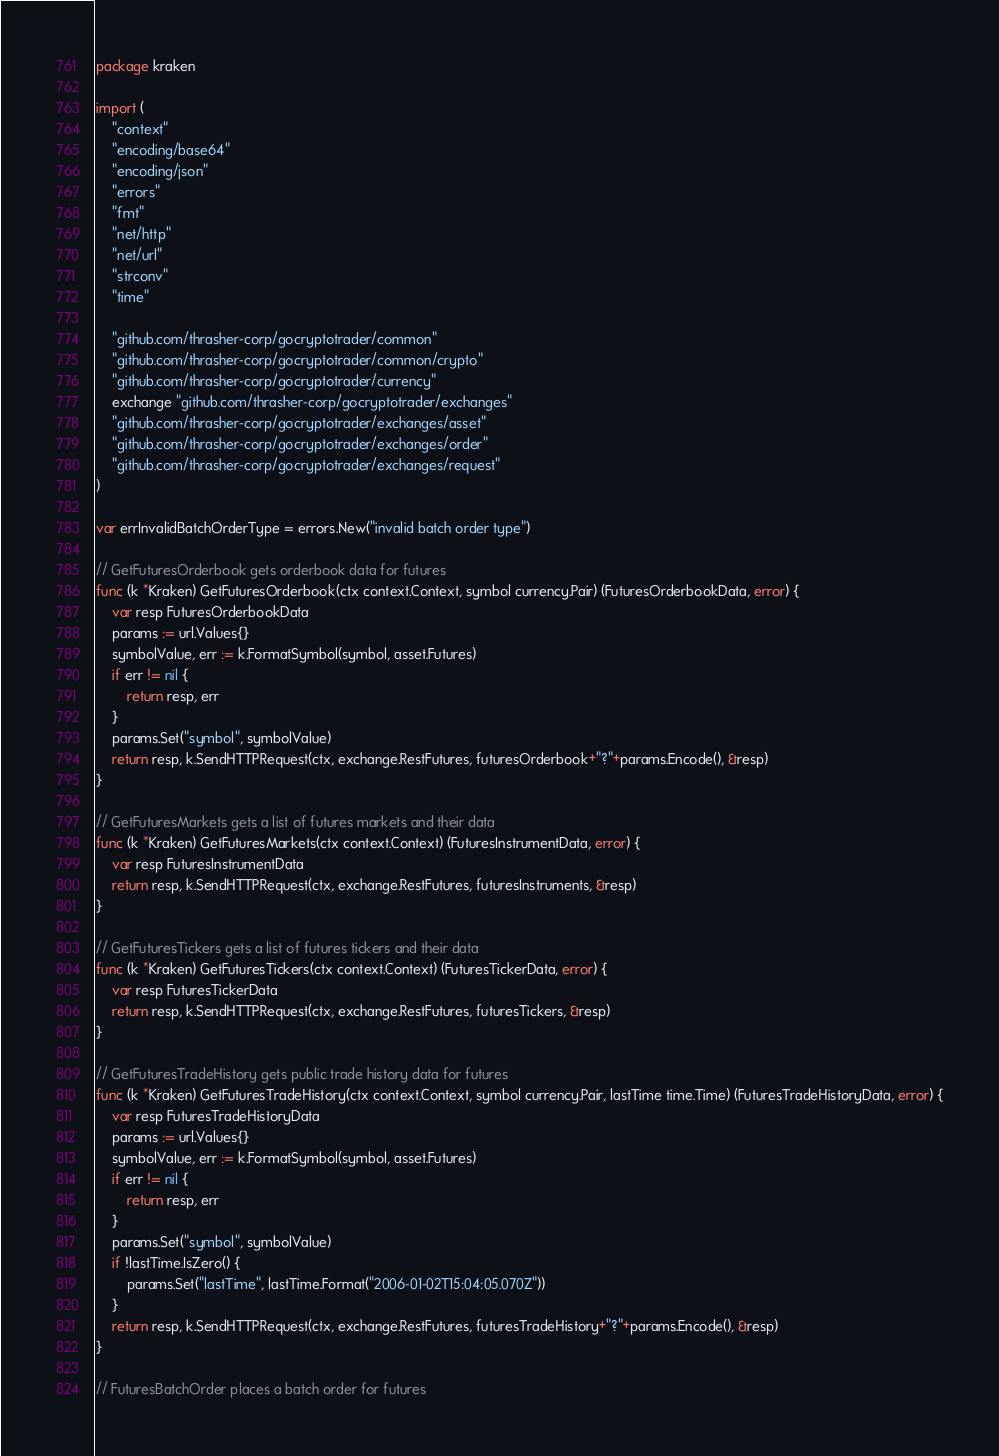<code> <loc_0><loc_0><loc_500><loc_500><_Go_>package kraken

import (
	"context"
	"encoding/base64"
	"encoding/json"
	"errors"
	"fmt"
	"net/http"
	"net/url"
	"strconv"
	"time"

	"github.com/thrasher-corp/gocryptotrader/common"
	"github.com/thrasher-corp/gocryptotrader/common/crypto"
	"github.com/thrasher-corp/gocryptotrader/currency"
	exchange "github.com/thrasher-corp/gocryptotrader/exchanges"
	"github.com/thrasher-corp/gocryptotrader/exchanges/asset"
	"github.com/thrasher-corp/gocryptotrader/exchanges/order"
	"github.com/thrasher-corp/gocryptotrader/exchanges/request"
)

var errInvalidBatchOrderType = errors.New("invalid batch order type")

// GetFuturesOrderbook gets orderbook data for futures
func (k *Kraken) GetFuturesOrderbook(ctx context.Context, symbol currency.Pair) (FuturesOrderbookData, error) {
	var resp FuturesOrderbookData
	params := url.Values{}
	symbolValue, err := k.FormatSymbol(symbol, asset.Futures)
	if err != nil {
		return resp, err
	}
	params.Set("symbol", symbolValue)
	return resp, k.SendHTTPRequest(ctx, exchange.RestFutures, futuresOrderbook+"?"+params.Encode(), &resp)
}

// GetFuturesMarkets gets a list of futures markets and their data
func (k *Kraken) GetFuturesMarkets(ctx context.Context) (FuturesInstrumentData, error) {
	var resp FuturesInstrumentData
	return resp, k.SendHTTPRequest(ctx, exchange.RestFutures, futuresInstruments, &resp)
}

// GetFuturesTickers gets a list of futures tickers and their data
func (k *Kraken) GetFuturesTickers(ctx context.Context) (FuturesTickerData, error) {
	var resp FuturesTickerData
	return resp, k.SendHTTPRequest(ctx, exchange.RestFutures, futuresTickers, &resp)
}

// GetFuturesTradeHistory gets public trade history data for futures
func (k *Kraken) GetFuturesTradeHistory(ctx context.Context, symbol currency.Pair, lastTime time.Time) (FuturesTradeHistoryData, error) {
	var resp FuturesTradeHistoryData
	params := url.Values{}
	symbolValue, err := k.FormatSymbol(symbol, asset.Futures)
	if err != nil {
		return resp, err
	}
	params.Set("symbol", symbolValue)
	if !lastTime.IsZero() {
		params.Set("lastTime", lastTime.Format("2006-01-02T15:04:05.070Z"))
	}
	return resp, k.SendHTTPRequest(ctx, exchange.RestFutures, futuresTradeHistory+"?"+params.Encode(), &resp)
}

// FuturesBatchOrder places a batch order for futures</code> 